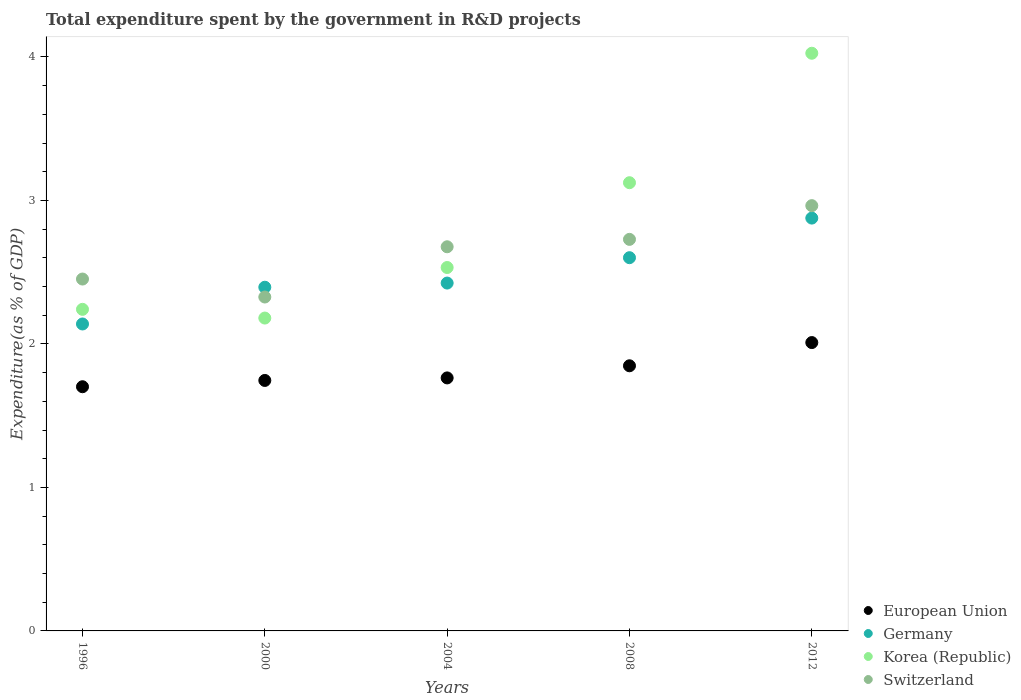How many different coloured dotlines are there?
Offer a terse response. 4. What is the total expenditure spent by the government in R&D projects in European Union in 2012?
Offer a terse response. 2.01. Across all years, what is the maximum total expenditure spent by the government in R&D projects in Germany?
Provide a short and direct response. 2.88. Across all years, what is the minimum total expenditure spent by the government in R&D projects in Germany?
Offer a very short reply. 2.14. What is the total total expenditure spent by the government in R&D projects in Germany in the graph?
Provide a succinct answer. 12.44. What is the difference between the total expenditure spent by the government in R&D projects in European Union in 2000 and that in 2008?
Offer a terse response. -0.1. What is the difference between the total expenditure spent by the government in R&D projects in European Union in 2004 and the total expenditure spent by the government in R&D projects in Korea (Republic) in 2008?
Provide a short and direct response. -1.36. What is the average total expenditure spent by the government in R&D projects in Germany per year?
Your response must be concise. 2.49. In the year 2004, what is the difference between the total expenditure spent by the government in R&D projects in Switzerland and total expenditure spent by the government in R&D projects in Korea (Republic)?
Offer a terse response. 0.14. In how many years, is the total expenditure spent by the government in R&D projects in Korea (Republic) greater than 0.4 %?
Your answer should be very brief. 5. What is the ratio of the total expenditure spent by the government in R&D projects in Germany in 2000 to that in 2008?
Keep it short and to the point. 0.92. Is the total expenditure spent by the government in R&D projects in Korea (Republic) in 1996 less than that in 2004?
Provide a short and direct response. Yes. What is the difference between the highest and the second highest total expenditure spent by the government in R&D projects in Korea (Republic)?
Give a very brief answer. 0.9. What is the difference between the highest and the lowest total expenditure spent by the government in R&D projects in European Union?
Offer a very short reply. 0.31. In how many years, is the total expenditure spent by the government in R&D projects in Switzerland greater than the average total expenditure spent by the government in R&D projects in Switzerland taken over all years?
Ensure brevity in your answer.  3. Is the sum of the total expenditure spent by the government in R&D projects in Germany in 1996 and 2000 greater than the maximum total expenditure spent by the government in R&D projects in European Union across all years?
Offer a very short reply. Yes. Is it the case that in every year, the sum of the total expenditure spent by the government in R&D projects in European Union and total expenditure spent by the government in R&D projects in Germany  is greater than the sum of total expenditure spent by the government in R&D projects in Switzerland and total expenditure spent by the government in R&D projects in Korea (Republic)?
Ensure brevity in your answer.  No. Is the total expenditure spent by the government in R&D projects in Korea (Republic) strictly greater than the total expenditure spent by the government in R&D projects in European Union over the years?
Provide a short and direct response. Yes. How many years are there in the graph?
Offer a terse response. 5. What is the difference between two consecutive major ticks on the Y-axis?
Ensure brevity in your answer.  1. Does the graph contain any zero values?
Offer a very short reply. No. Where does the legend appear in the graph?
Your answer should be very brief. Bottom right. How many legend labels are there?
Your answer should be compact. 4. How are the legend labels stacked?
Ensure brevity in your answer.  Vertical. What is the title of the graph?
Provide a short and direct response. Total expenditure spent by the government in R&D projects. What is the label or title of the X-axis?
Your response must be concise. Years. What is the label or title of the Y-axis?
Offer a very short reply. Expenditure(as % of GDP). What is the Expenditure(as % of GDP) of European Union in 1996?
Your answer should be very brief. 1.7. What is the Expenditure(as % of GDP) of Germany in 1996?
Make the answer very short. 2.14. What is the Expenditure(as % of GDP) of Korea (Republic) in 1996?
Your answer should be very brief. 2.24. What is the Expenditure(as % of GDP) in Switzerland in 1996?
Give a very brief answer. 2.45. What is the Expenditure(as % of GDP) of European Union in 2000?
Give a very brief answer. 1.75. What is the Expenditure(as % of GDP) of Germany in 2000?
Keep it short and to the point. 2.4. What is the Expenditure(as % of GDP) in Korea (Republic) in 2000?
Ensure brevity in your answer.  2.18. What is the Expenditure(as % of GDP) in Switzerland in 2000?
Provide a short and direct response. 2.33. What is the Expenditure(as % of GDP) of European Union in 2004?
Offer a terse response. 1.76. What is the Expenditure(as % of GDP) in Germany in 2004?
Ensure brevity in your answer.  2.42. What is the Expenditure(as % of GDP) in Korea (Republic) in 2004?
Offer a terse response. 2.53. What is the Expenditure(as % of GDP) in Switzerland in 2004?
Offer a terse response. 2.68. What is the Expenditure(as % of GDP) in European Union in 2008?
Offer a very short reply. 1.85. What is the Expenditure(as % of GDP) of Germany in 2008?
Keep it short and to the point. 2.6. What is the Expenditure(as % of GDP) in Korea (Republic) in 2008?
Ensure brevity in your answer.  3.12. What is the Expenditure(as % of GDP) of Switzerland in 2008?
Your answer should be very brief. 2.73. What is the Expenditure(as % of GDP) of European Union in 2012?
Give a very brief answer. 2.01. What is the Expenditure(as % of GDP) in Germany in 2012?
Your answer should be very brief. 2.88. What is the Expenditure(as % of GDP) in Korea (Republic) in 2012?
Make the answer very short. 4.03. What is the Expenditure(as % of GDP) of Switzerland in 2012?
Your answer should be compact. 2.96. Across all years, what is the maximum Expenditure(as % of GDP) in European Union?
Offer a very short reply. 2.01. Across all years, what is the maximum Expenditure(as % of GDP) in Germany?
Give a very brief answer. 2.88. Across all years, what is the maximum Expenditure(as % of GDP) in Korea (Republic)?
Offer a very short reply. 4.03. Across all years, what is the maximum Expenditure(as % of GDP) of Switzerland?
Give a very brief answer. 2.96. Across all years, what is the minimum Expenditure(as % of GDP) in European Union?
Your answer should be compact. 1.7. Across all years, what is the minimum Expenditure(as % of GDP) of Germany?
Make the answer very short. 2.14. Across all years, what is the minimum Expenditure(as % of GDP) of Korea (Republic)?
Make the answer very short. 2.18. Across all years, what is the minimum Expenditure(as % of GDP) of Switzerland?
Keep it short and to the point. 2.33. What is the total Expenditure(as % of GDP) in European Union in the graph?
Ensure brevity in your answer.  9.07. What is the total Expenditure(as % of GDP) in Germany in the graph?
Provide a short and direct response. 12.44. What is the total Expenditure(as % of GDP) of Korea (Republic) in the graph?
Provide a short and direct response. 14.1. What is the total Expenditure(as % of GDP) of Switzerland in the graph?
Provide a short and direct response. 13.15. What is the difference between the Expenditure(as % of GDP) of European Union in 1996 and that in 2000?
Make the answer very short. -0.04. What is the difference between the Expenditure(as % of GDP) in Germany in 1996 and that in 2000?
Provide a short and direct response. -0.26. What is the difference between the Expenditure(as % of GDP) of Korea (Republic) in 1996 and that in 2000?
Offer a terse response. 0.06. What is the difference between the Expenditure(as % of GDP) of Switzerland in 1996 and that in 2000?
Your answer should be very brief. 0.13. What is the difference between the Expenditure(as % of GDP) in European Union in 1996 and that in 2004?
Your answer should be compact. -0.06. What is the difference between the Expenditure(as % of GDP) of Germany in 1996 and that in 2004?
Provide a succinct answer. -0.29. What is the difference between the Expenditure(as % of GDP) of Korea (Republic) in 1996 and that in 2004?
Keep it short and to the point. -0.29. What is the difference between the Expenditure(as % of GDP) in Switzerland in 1996 and that in 2004?
Your answer should be very brief. -0.22. What is the difference between the Expenditure(as % of GDP) of European Union in 1996 and that in 2008?
Your answer should be very brief. -0.15. What is the difference between the Expenditure(as % of GDP) of Germany in 1996 and that in 2008?
Your response must be concise. -0.46. What is the difference between the Expenditure(as % of GDP) in Korea (Republic) in 1996 and that in 2008?
Offer a very short reply. -0.88. What is the difference between the Expenditure(as % of GDP) in Switzerland in 1996 and that in 2008?
Keep it short and to the point. -0.28. What is the difference between the Expenditure(as % of GDP) of European Union in 1996 and that in 2012?
Ensure brevity in your answer.  -0.31. What is the difference between the Expenditure(as % of GDP) of Germany in 1996 and that in 2012?
Provide a succinct answer. -0.74. What is the difference between the Expenditure(as % of GDP) in Korea (Republic) in 1996 and that in 2012?
Provide a succinct answer. -1.78. What is the difference between the Expenditure(as % of GDP) of Switzerland in 1996 and that in 2012?
Make the answer very short. -0.51. What is the difference between the Expenditure(as % of GDP) in European Union in 2000 and that in 2004?
Offer a very short reply. -0.02. What is the difference between the Expenditure(as % of GDP) of Germany in 2000 and that in 2004?
Provide a succinct answer. -0.03. What is the difference between the Expenditure(as % of GDP) of Korea (Republic) in 2000 and that in 2004?
Your response must be concise. -0.35. What is the difference between the Expenditure(as % of GDP) in Switzerland in 2000 and that in 2004?
Make the answer very short. -0.35. What is the difference between the Expenditure(as % of GDP) in European Union in 2000 and that in 2008?
Your answer should be compact. -0.1. What is the difference between the Expenditure(as % of GDP) of Germany in 2000 and that in 2008?
Keep it short and to the point. -0.21. What is the difference between the Expenditure(as % of GDP) of Korea (Republic) in 2000 and that in 2008?
Offer a terse response. -0.94. What is the difference between the Expenditure(as % of GDP) of Switzerland in 2000 and that in 2008?
Your answer should be very brief. -0.4. What is the difference between the Expenditure(as % of GDP) of European Union in 2000 and that in 2012?
Offer a terse response. -0.26. What is the difference between the Expenditure(as % of GDP) of Germany in 2000 and that in 2012?
Provide a short and direct response. -0.48. What is the difference between the Expenditure(as % of GDP) of Korea (Republic) in 2000 and that in 2012?
Your response must be concise. -1.85. What is the difference between the Expenditure(as % of GDP) of Switzerland in 2000 and that in 2012?
Your response must be concise. -0.64. What is the difference between the Expenditure(as % of GDP) in European Union in 2004 and that in 2008?
Ensure brevity in your answer.  -0.08. What is the difference between the Expenditure(as % of GDP) in Germany in 2004 and that in 2008?
Offer a very short reply. -0.18. What is the difference between the Expenditure(as % of GDP) in Korea (Republic) in 2004 and that in 2008?
Your answer should be compact. -0.59. What is the difference between the Expenditure(as % of GDP) in Switzerland in 2004 and that in 2008?
Keep it short and to the point. -0.05. What is the difference between the Expenditure(as % of GDP) in European Union in 2004 and that in 2012?
Provide a succinct answer. -0.25. What is the difference between the Expenditure(as % of GDP) in Germany in 2004 and that in 2012?
Make the answer very short. -0.45. What is the difference between the Expenditure(as % of GDP) in Korea (Republic) in 2004 and that in 2012?
Provide a succinct answer. -1.49. What is the difference between the Expenditure(as % of GDP) of Switzerland in 2004 and that in 2012?
Provide a succinct answer. -0.29. What is the difference between the Expenditure(as % of GDP) of European Union in 2008 and that in 2012?
Provide a succinct answer. -0.16. What is the difference between the Expenditure(as % of GDP) in Germany in 2008 and that in 2012?
Keep it short and to the point. -0.28. What is the difference between the Expenditure(as % of GDP) in Korea (Republic) in 2008 and that in 2012?
Provide a succinct answer. -0.9. What is the difference between the Expenditure(as % of GDP) of Switzerland in 2008 and that in 2012?
Give a very brief answer. -0.23. What is the difference between the Expenditure(as % of GDP) in European Union in 1996 and the Expenditure(as % of GDP) in Germany in 2000?
Your answer should be compact. -0.69. What is the difference between the Expenditure(as % of GDP) in European Union in 1996 and the Expenditure(as % of GDP) in Korea (Republic) in 2000?
Ensure brevity in your answer.  -0.48. What is the difference between the Expenditure(as % of GDP) in European Union in 1996 and the Expenditure(as % of GDP) in Switzerland in 2000?
Your answer should be very brief. -0.63. What is the difference between the Expenditure(as % of GDP) of Germany in 1996 and the Expenditure(as % of GDP) of Korea (Republic) in 2000?
Offer a terse response. -0.04. What is the difference between the Expenditure(as % of GDP) in Germany in 1996 and the Expenditure(as % of GDP) in Switzerland in 2000?
Ensure brevity in your answer.  -0.19. What is the difference between the Expenditure(as % of GDP) in Korea (Republic) in 1996 and the Expenditure(as % of GDP) in Switzerland in 2000?
Provide a short and direct response. -0.09. What is the difference between the Expenditure(as % of GDP) of European Union in 1996 and the Expenditure(as % of GDP) of Germany in 2004?
Your response must be concise. -0.72. What is the difference between the Expenditure(as % of GDP) in European Union in 1996 and the Expenditure(as % of GDP) in Korea (Republic) in 2004?
Keep it short and to the point. -0.83. What is the difference between the Expenditure(as % of GDP) of European Union in 1996 and the Expenditure(as % of GDP) of Switzerland in 2004?
Offer a very short reply. -0.98. What is the difference between the Expenditure(as % of GDP) of Germany in 1996 and the Expenditure(as % of GDP) of Korea (Republic) in 2004?
Your answer should be compact. -0.39. What is the difference between the Expenditure(as % of GDP) in Germany in 1996 and the Expenditure(as % of GDP) in Switzerland in 2004?
Your answer should be very brief. -0.54. What is the difference between the Expenditure(as % of GDP) of Korea (Republic) in 1996 and the Expenditure(as % of GDP) of Switzerland in 2004?
Provide a short and direct response. -0.44. What is the difference between the Expenditure(as % of GDP) of European Union in 1996 and the Expenditure(as % of GDP) of Germany in 2008?
Provide a succinct answer. -0.9. What is the difference between the Expenditure(as % of GDP) of European Union in 1996 and the Expenditure(as % of GDP) of Korea (Republic) in 2008?
Keep it short and to the point. -1.42. What is the difference between the Expenditure(as % of GDP) of European Union in 1996 and the Expenditure(as % of GDP) of Switzerland in 2008?
Offer a very short reply. -1.03. What is the difference between the Expenditure(as % of GDP) in Germany in 1996 and the Expenditure(as % of GDP) in Korea (Republic) in 2008?
Give a very brief answer. -0.98. What is the difference between the Expenditure(as % of GDP) of Germany in 1996 and the Expenditure(as % of GDP) of Switzerland in 2008?
Give a very brief answer. -0.59. What is the difference between the Expenditure(as % of GDP) of Korea (Republic) in 1996 and the Expenditure(as % of GDP) of Switzerland in 2008?
Make the answer very short. -0.49. What is the difference between the Expenditure(as % of GDP) of European Union in 1996 and the Expenditure(as % of GDP) of Germany in 2012?
Your answer should be compact. -1.18. What is the difference between the Expenditure(as % of GDP) of European Union in 1996 and the Expenditure(as % of GDP) of Korea (Republic) in 2012?
Offer a very short reply. -2.32. What is the difference between the Expenditure(as % of GDP) of European Union in 1996 and the Expenditure(as % of GDP) of Switzerland in 2012?
Provide a succinct answer. -1.26. What is the difference between the Expenditure(as % of GDP) of Germany in 1996 and the Expenditure(as % of GDP) of Korea (Republic) in 2012?
Provide a succinct answer. -1.89. What is the difference between the Expenditure(as % of GDP) of Germany in 1996 and the Expenditure(as % of GDP) of Switzerland in 2012?
Keep it short and to the point. -0.82. What is the difference between the Expenditure(as % of GDP) in Korea (Republic) in 1996 and the Expenditure(as % of GDP) in Switzerland in 2012?
Offer a terse response. -0.72. What is the difference between the Expenditure(as % of GDP) of European Union in 2000 and the Expenditure(as % of GDP) of Germany in 2004?
Your answer should be very brief. -0.68. What is the difference between the Expenditure(as % of GDP) of European Union in 2000 and the Expenditure(as % of GDP) of Korea (Republic) in 2004?
Give a very brief answer. -0.79. What is the difference between the Expenditure(as % of GDP) in European Union in 2000 and the Expenditure(as % of GDP) in Switzerland in 2004?
Your answer should be very brief. -0.93. What is the difference between the Expenditure(as % of GDP) of Germany in 2000 and the Expenditure(as % of GDP) of Korea (Republic) in 2004?
Offer a terse response. -0.14. What is the difference between the Expenditure(as % of GDP) in Germany in 2000 and the Expenditure(as % of GDP) in Switzerland in 2004?
Your response must be concise. -0.28. What is the difference between the Expenditure(as % of GDP) in Korea (Republic) in 2000 and the Expenditure(as % of GDP) in Switzerland in 2004?
Your answer should be compact. -0.5. What is the difference between the Expenditure(as % of GDP) in European Union in 2000 and the Expenditure(as % of GDP) in Germany in 2008?
Your answer should be compact. -0.86. What is the difference between the Expenditure(as % of GDP) of European Union in 2000 and the Expenditure(as % of GDP) of Korea (Republic) in 2008?
Make the answer very short. -1.38. What is the difference between the Expenditure(as % of GDP) in European Union in 2000 and the Expenditure(as % of GDP) in Switzerland in 2008?
Make the answer very short. -0.98. What is the difference between the Expenditure(as % of GDP) of Germany in 2000 and the Expenditure(as % of GDP) of Korea (Republic) in 2008?
Provide a succinct answer. -0.73. What is the difference between the Expenditure(as % of GDP) in Germany in 2000 and the Expenditure(as % of GDP) in Switzerland in 2008?
Provide a succinct answer. -0.33. What is the difference between the Expenditure(as % of GDP) in Korea (Republic) in 2000 and the Expenditure(as % of GDP) in Switzerland in 2008?
Your response must be concise. -0.55. What is the difference between the Expenditure(as % of GDP) in European Union in 2000 and the Expenditure(as % of GDP) in Germany in 2012?
Provide a succinct answer. -1.13. What is the difference between the Expenditure(as % of GDP) in European Union in 2000 and the Expenditure(as % of GDP) in Korea (Republic) in 2012?
Make the answer very short. -2.28. What is the difference between the Expenditure(as % of GDP) in European Union in 2000 and the Expenditure(as % of GDP) in Switzerland in 2012?
Provide a succinct answer. -1.22. What is the difference between the Expenditure(as % of GDP) of Germany in 2000 and the Expenditure(as % of GDP) of Korea (Republic) in 2012?
Your response must be concise. -1.63. What is the difference between the Expenditure(as % of GDP) in Germany in 2000 and the Expenditure(as % of GDP) in Switzerland in 2012?
Your answer should be compact. -0.57. What is the difference between the Expenditure(as % of GDP) of Korea (Republic) in 2000 and the Expenditure(as % of GDP) of Switzerland in 2012?
Provide a short and direct response. -0.78. What is the difference between the Expenditure(as % of GDP) in European Union in 2004 and the Expenditure(as % of GDP) in Germany in 2008?
Provide a succinct answer. -0.84. What is the difference between the Expenditure(as % of GDP) of European Union in 2004 and the Expenditure(as % of GDP) of Korea (Republic) in 2008?
Offer a terse response. -1.36. What is the difference between the Expenditure(as % of GDP) in European Union in 2004 and the Expenditure(as % of GDP) in Switzerland in 2008?
Ensure brevity in your answer.  -0.97. What is the difference between the Expenditure(as % of GDP) of Germany in 2004 and the Expenditure(as % of GDP) of Korea (Republic) in 2008?
Your response must be concise. -0.7. What is the difference between the Expenditure(as % of GDP) in Germany in 2004 and the Expenditure(as % of GDP) in Switzerland in 2008?
Your answer should be compact. -0.3. What is the difference between the Expenditure(as % of GDP) of Korea (Republic) in 2004 and the Expenditure(as % of GDP) of Switzerland in 2008?
Offer a terse response. -0.2. What is the difference between the Expenditure(as % of GDP) of European Union in 2004 and the Expenditure(as % of GDP) of Germany in 2012?
Ensure brevity in your answer.  -1.11. What is the difference between the Expenditure(as % of GDP) of European Union in 2004 and the Expenditure(as % of GDP) of Korea (Republic) in 2012?
Keep it short and to the point. -2.26. What is the difference between the Expenditure(as % of GDP) in European Union in 2004 and the Expenditure(as % of GDP) in Switzerland in 2012?
Offer a very short reply. -1.2. What is the difference between the Expenditure(as % of GDP) of Germany in 2004 and the Expenditure(as % of GDP) of Korea (Republic) in 2012?
Your answer should be compact. -1.6. What is the difference between the Expenditure(as % of GDP) in Germany in 2004 and the Expenditure(as % of GDP) in Switzerland in 2012?
Ensure brevity in your answer.  -0.54. What is the difference between the Expenditure(as % of GDP) of Korea (Republic) in 2004 and the Expenditure(as % of GDP) of Switzerland in 2012?
Your answer should be compact. -0.43. What is the difference between the Expenditure(as % of GDP) in European Union in 2008 and the Expenditure(as % of GDP) in Germany in 2012?
Provide a short and direct response. -1.03. What is the difference between the Expenditure(as % of GDP) of European Union in 2008 and the Expenditure(as % of GDP) of Korea (Republic) in 2012?
Offer a very short reply. -2.18. What is the difference between the Expenditure(as % of GDP) in European Union in 2008 and the Expenditure(as % of GDP) in Switzerland in 2012?
Give a very brief answer. -1.12. What is the difference between the Expenditure(as % of GDP) of Germany in 2008 and the Expenditure(as % of GDP) of Korea (Republic) in 2012?
Offer a very short reply. -1.42. What is the difference between the Expenditure(as % of GDP) of Germany in 2008 and the Expenditure(as % of GDP) of Switzerland in 2012?
Make the answer very short. -0.36. What is the difference between the Expenditure(as % of GDP) of Korea (Republic) in 2008 and the Expenditure(as % of GDP) of Switzerland in 2012?
Your answer should be compact. 0.16. What is the average Expenditure(as % of GDP) in European Union per year?
Your answer should be very brief. 1.81. What is the average Expenditure(as % of GDP) of Germany per year?
Offer a terse response. 2.49. What is the average Expenditure(as % of GDP) in Korea (Republic) per year?
Provide a short and direct response. 2.82. What is the average Expenditure(as % of GDP) of Switzerland per year?
Keep it short and to the point. 2.63. In the year 1996, what is the difference between the Expenditure(as % of GDP) in European Union and Expenditure(as % of GDP) in Germany?
Ensure brevity in your answer.  -0.44. In the year 1996, what is the difference between the Expenditure(as % of GDP) of European Union and Expenditure(as % of GDP) of Korea (Republic)?
Offer a terse response. -0.54. In the year 1996, what is the difference between the Expenditure(as % of GDP) in European Union and Expenditure(as % of GDP) in Switzerland?
Ensure brevity in your answer.  -0.75. In the year 1996, what is the difference between the Expenditure(as % of GDP) of Germany and Expenditure(as % of GDP) of Korea (Republic)?
Offer a very short reply. -0.1. In the year 1996, what is the difference between the Expenditure(as % of GDP) in Germany and Expenditure(as % of GDP) in Switzerland?
Your answer should be very brief. -0.31. In the year 1996, what is the difference between the Expenditure(as % of GDP) in Korea (Republic) and Expenditure(as % of GDP) in Switzerland?
Offer a terse response. -0.21. In the year 2000, what is the difference between the Expenditure(as % of GDP) of European Union and Expenditure(as % of GDP) of Germany?
Your answer should be very brief. -0.65. In the year 2000, what is the difference between the Expenditure(as % of GDP) of European Union and Expenditure(as % of GDP) of Korea (Republic)?
Ensure brevity in your answer.  -0.43. In the year 2000, what is the difference between the Expenditure(as % of GDP) in European Union and Expenditure(as % of GDP) in Switzerland?
Your answer should be compact. -0.58. In the year 2000, what is the difference between the Expenditure(as % of GDP) in Germany and Expenditure(as % of GDP) in Korea (Republic)?
Your response must be concise. 0.21. In the year 2000, what is the difference between the Expenditure(as % of GDP) of Germany and Expenditure(as % of GDP) of Switzerland?
Ensure brevity in your answer.  0.07. In the year 2000, what is the difference between the Expenditure(as % of GDP) in Korea (Republic) and Expenditure(as % of GDP) in Switzerland?
Provide a succinct answer. -0.15. In the year 2004, what is the difference between the Expenditure(as % of GDP) of European Union and Expenditure(as % of GDP) of Germany?
Give a very brief answer. -0.66. In the year 2004, what is the difference between the Expenditure(as % of GDP) in European Union and Expenditure(as % of GDP) in Korea (Republic)?
Offer a terse response. -0.77. In the year 2004, what is the difference between the Expenditure(as % of GDP) in European Union and Expenditure(as % of GDP) in Switzerland?
Keep it short and to the point. -0.91. In the year 2004, what is the difference between the Expenditure(as % of GDP) in Germany and Expenditure(as % of GDP) in Korea (Republic)?
Offer a very short reply. -0.11. In the year 2004, what is the difference between the Expenditure(as % of GDP) of Germany and Expenditure(as % of GDP) of Switzerland?
Offer a very short reply. -0.25. In the year 2004, what is the difference between the Expenditure(as % of GDP) of Korea (Republic) and Expenditure(as % of GDP) of Switzerland?
Offer a very short reply. -0.14. In the year 2008, what is the difference between the Expenditure(as % of GDP) of European Union and Expenditure(as % of GDP) of Germany?
Your response must be concise. -0.75. In the year 2008, what is the difference between the Expenditure(as % of GDP) of European Union and Expenditure(as % of GDP) of Korea (Republic)?
Make the answer very short. -1.28. In the year 2008, what is the difference between the Expenditure(as % of GDP) in European Union and Expenditure(as % of GDP) in Switzerland?
Offer a terse response. -0.88. In the year 2008, what is the difference between the Expenditure(as % of GDP) of Germany and Expenditure(as % of GDP) of Korea (Republic)?
Offer a very short reply. -0.52. In the year 2008, what is the difference between the Expenditure(as % of GDP) in Germany and Expenditure(as % of GDP) in Switzerland?
Make the answer very short. -0.13. In the year 2008, what is the difference between the Expenditure(as % of GDP) in Korea (Republic) and Expenditure(as % of GDP) in Switzerland?
Provide a succinct answer. 0.39. In the year 2012, what is the difference between the Expenditure(as % of GDP) of European Union and Expenditure(as % of GDP) of Germany?
Offer a terse response. -0.87. In the year 2012, what is the difference between the Expenditure(as % of GDP) in European Union and Expenditure(as % of GDP) in Korea (Republic)?
Make the answer very short. -2.02. In the year 2012, what is the difference between the Expenditure(as % of GDP) of European Union and Expenditure(as % of GDP) of Switzerland?
Make the answer very short. -0.95. In the year 2012, what is the difference between the Expenditure(as % of GDP) of Germany and Expenditure(as % of GDP) of Korea (Republic)?
Keep it short and to the point. -1.15. In the year 2012, what is the difference between the Expenditure(as % of GDP) of Germany and Expenditure(as % of GDP) of Switzerland?
Your answer should be compact. -0.09. In the year 2012, what is the difference between the Expenditure(as % of GDP) in Korea (Republic) and Expenditure(as % of GDP) in Switzerland?
Give a very brief answer. 1.06. What is the ratio of the Expenditure(as % of GDP) in European Union in 1996 to that in 2000?
Make the answer very short. 0.97. What is the ratio of the Expenditure(as % of GDP) in Germany in 1996 to that in 2000?
Offer a terse response. 0.89. What is the ratio of the Expenditure(as % of GDP) in Korea (Republic) in 1996 to that in 2000?
Offer a terse response. 1.03. What is the ratio of the Expenditure(as % of GDP) in Switzerland in 1996 to that in 2000?
Your response must be concise. 1.05. What is the ratio of the Expenditure(as % of GDP) of European Union in 1996 to that in 2004?
Your response must be concise. 0.97. What is the ratio of the Expenditure(as % of GDP) in Germany in 1996 to that in 2004?
Make the answer very short. 0.88. What is the ratio of the Expenditure(as % of GDP) in Korea (Republic) in 1996 to that in 2004?
Give a very brief answer. 0.88. What is the ratio of the Expenditure(as % of GDP) of Switzerland in 1996 to that in 2004?
Your response must be concise. 0.92. What is the ratio of the Expenditure(as % of GDP) of European Union in 1996 to that in 2008?
Your answer should be very brief. 0.92. What is the ratio of the Expenditure(as % of GDP) in Germany in 1996 to that in 2008?
Provide a succinct answer. 0.82. What is the ratio of the Expenditure(as % of GDP) of Korea (Republic) in 1996 to that in 2008?
Keep it short and to the point. 0.72. What is the ratio of the Expenditure(as % of GDP) in Switzerland in 1996 to that in 2008?
Your answer should be very brief. 0.9. What is the ratio of the Expenditure(as % of GDP) of European Union in 1996 to that in 2012?
Ensure brevity in your answer.  0.85. What is the ratio of the Expenditure(as % of GDP) of Germany in 1996 to that in 2012?
Keep it short and to the point. 0.74. What is the ratio of the Expenditure(as % of GDP) of Korea (Republic) in 1996 to that in 2012?
Give a very brief answer. 0.56. What is the ratio of the Expenditure(as % of GDP) in Switzerland in 1996 to that in 2012?
Your response must be concise. 0.83. What is the ratio of the Expenditure(as % of GDP) in Korea (Republic) in 2000 to that in 2004?
Your answer should be very brief. 0.86. What is the ratio of the Expenditure(as % of GDP) of Switzerland in 2000 to that in 2004?
Your answer should be very brief. 0.87. What is the ratio of the Expenditure(as % of GDP) in European Union in 2000 to that in 2008?
Your response must be concise. 0.94. What is the ratio of the Expenditure(as % of GDP) in Germany in 2000 to that in 2008?
Provide a succinct answer. 0.92. What is the ratio of the Expenditure(as % of GDP) in Korea (Republic) in 2000 to that in 2008?
Offer a terse response. 0.7. What is the ratio of the Expenditure(as % of GDP) of Switzerland in 2000 to that in 2008?
Offer a terse response. 0.85. What is the ratio of the Expenditure(as % of GDP) in European Union in 2000 to that in 2012?
Provide a succinct answer. 0.87. What is the ratio of the Expenditure(as % of GDP) in Germany in 2000 to that in 2012?
Your answer should be very brief. 0.83. What is the ratio of the Expenditure(as % of GDP) of Korea (Republic) in 2000 to that in 2012?
Ensure brevity in your answer.  0.54. What is the ratio of the Expenditure(as % of GDP) in Switzerland in 2000 to that in 2012?
Your answer should be very brief. 0.79. What is the ratio of the Expenditure(as % of GDP) in European Union in 2004 to that in 2008?
Provide a short and direct response. 0.95. What is the ratio of the Expenditure(as % of GDP) of Germany in 2004 to that in 2008?
Your answer should be very brief. 0.93. What is the ratio of the Expenditure(as % of GDP) of Korea (Republic) in 2004 to that in 2008?
Provide a succinct answer. 0.81. What is the ratio of the Expenditure(as % of GDP) in Switzerland in 2004 to that in 2008?
Offer a terse response. 0.98. What is the ratio of the Expenditure(as % of GDP) in European Union in 2004 to that in 2012?
Keep it short and to the point. 0.88. What is the ratio of the Expenditure(as % of GDP) of Germany in 2004 to that in 2012?
Your answer should be compact. 0.84. What is the ratio of the Expenditure(as % of GDP) of Korea (Republic) in 2004 to that in 2012?
Keep it short and to the point. 0.63. What is the ratio of the Expenditure(as % of GDP) of Switzerland in 2004 to that in 2012?
Give a very brief answer. 0.9. What is the ratio of the Expenditure(as % of GDP) in European Union in 2008 to that in 2012?
Provide a short and direct response. 0.92. What is the ratio of the Expenditure(as % of GDP) of Germany in 2008 to that in 2012?
Make the answer very short. 0.9. What is the ratio of the Expenditure(as % of GDP) in Korea (Republic) in 2008 to that in 2012?
Give a very brief answer. 0.78. What is the ratio of the Expenditure(as % of GDP) in Switzerland in 2008 to that in 2012?
Provide a short and direct response. 0.92. What is the difference between the highest and the second highest Expenditure(as % of GDP) of European Union?
Provide a short and direct response. 0.16. What is the difference between the highest and the second highest Expenditure(as % of GDP) in Germany?
Offer a very short reply. 0.28. What is the difference between the highest and the second highest Expenditure(as % of GDP) in Korea (Republic)?
Provide a succinct answer. 0.9. What is the difference between the highest and the second highest Expenditure(as % of GDP) of Switzerland?
Ensure brevity in your answer.  0.23. What is the difference between the highest and the lowest Expenditure(as % of GDP) of European Union?
Your response must be concise. 0.31. What is the difference between the highest and the lowest Expenditure(as % of GDP) in Germany?
Make the answer very short. 0.74. What is the difference between the highest and the lowest Expenditure(as % of GDP) in Korea (Republic)?
Ensure brevity in your answer.  1.85. What is the difference between the highest and the lowest Expenditure(as % of GDP) of Switzerland?
Ensure brevity in your answer.  0.64. 